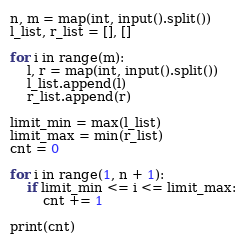<code> <loc_0><loc_0><loc_500><loc_500><_Python_>n, m = map(int, input().split())
l_list, r_list = [], []

for i in range(m):
	l, r = map(int, input().split())
	l_list.append(l)
	r_list.append(r)

limit_min = max(l_list)
limit_max = min(r_list)
cnt = 0

for i in range(1, n + 1):
	if limit_min <= i <= limit_max:
		cnt += 1

print(cnt)
</code> 